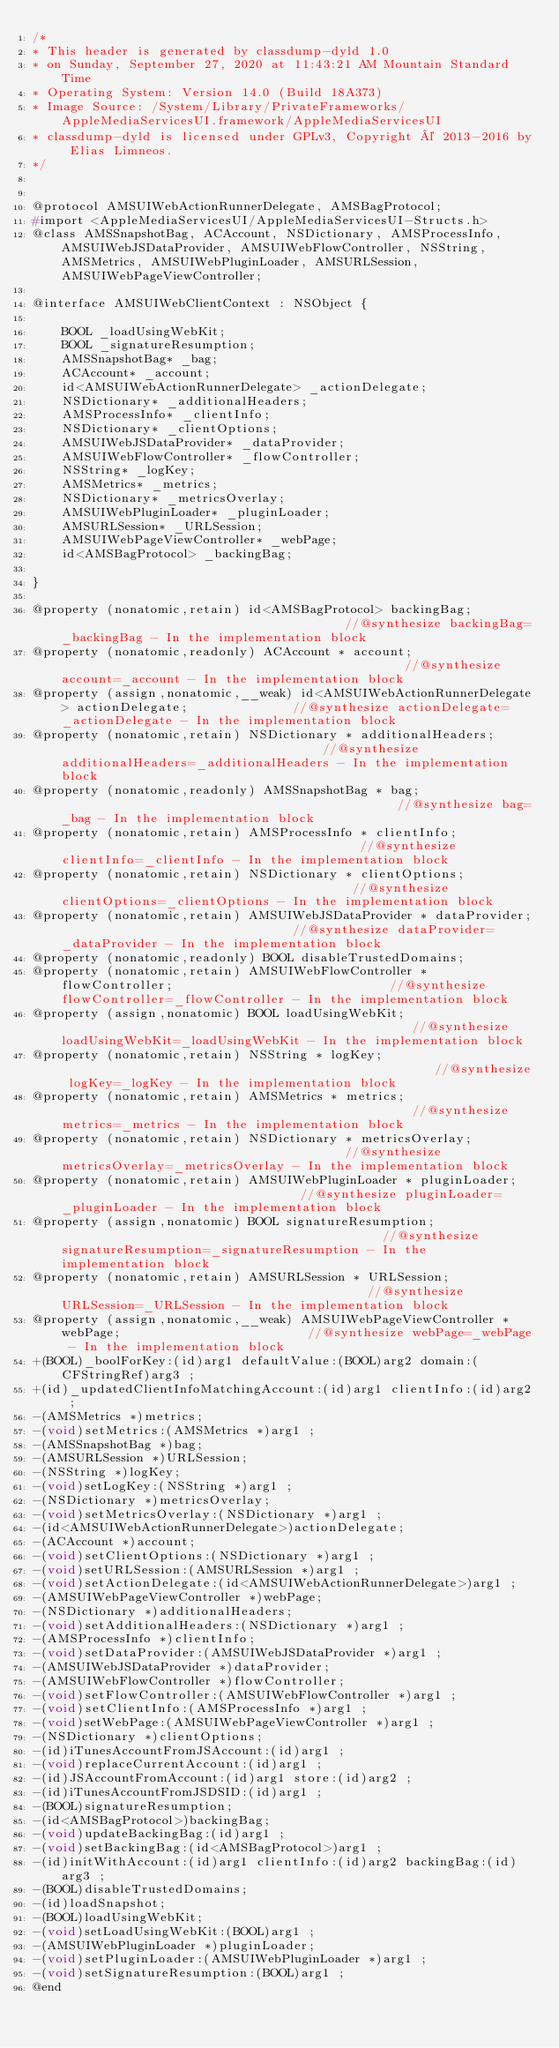<code> <loc_0><loc_0><loc_500><loc_500><_C_>/*
* This header is generated by classdump-dyld 1.0
* on Sunday, September 27, 2020 at 11:43:21 AM Mountain Standard Time
* Operating System: Version 14.0 (Build 18A373)
* Image Source: /System/Library/PrivateFrameworks/AppleMediaServicesUI.framework/AppleMediaServicesUI
* classdump-dyld is licensed under GPLv3, Copyright © 2013-2016 by Elias Limneos.
*/


@protocol AMSUIWebActionRunnerDelegate, AMSBagProtocol;
#import <AppleMediaServicesUI/AppleMediaServicesUI-Structs.h>
@class AMSSnapshotBag, ACAccount, NSDictionary, AMSProcessInfo, AMSUIWebJSDataProvider, AMSUIWebFlowController, NSString, AMSMetrics, AMSUIWebPluginLoader, AMSURLSession, AMSUIWebPageViewController;

@interface AMSUIWebClientContext : NSObject {

	BOOL _loadUsingWebKit;
	BOOL _signatureResumption;
	AMSSnapshotBag* _bag;
	ACAccount* _account;
	id<AMSUIWebActionRunnerDelegate> _actionDelegate;
	NSDictionary* _additionalHeaders;
	AMSProcessInfo* _clientInfo;
	NSDictionary* _clientOptions;
	AMSUIWebJSDataProvider* _dataProvider;
	AMSUIWebFlowController* _flowController;
	NSString* _logKey;
	AMSMetrics* _metrics;
	NSDictionary* _metricsOverlay;
	AMSUIWebPluginLoader* _pluginLoader;
	AMSURLSession* _URLSession;
	AMSUIWebPageViewController* _webPage;
	id<AMSBagProtocol> _backingBag;

}

@property (nonatomic,retain) id<AMSBagProtocol> backingBag;                                       //@synthesize backingBag=_backingBag - In the implementation block
@property (nonatomic,readonly) ACAccount * account;                                               //@synthesize account=_account - In the implementation block
@property (assign,nonatomic,__weak) id<AMSUIWebActionRunnerDelegate> actionDelegate;              //@synthesize actionDelegate=_actionDelegate - In the implementation block
@property (nonatomic,retain) NSDictionary * additionalHeaders;                                    //@synthesize additionalHeaders=_additionalHeaders - In the implementation block
@property (nonatomic,readonly) AMSSnapshotBag * bag;                                              //@synthesize bag=_bag - In the implementation block
@property (nonatomic,retain) AMSProcessInfo * clientInfo;                                         //@synthesize clientInfo=_clientInfo - In the implementation block
@property (nonatomic,retain) NSDictionary * clientOptions;                                        //@synthesize clientOptions=_clientOptions - In the implementation block
@property (nonatomic,retain) AMSUIWebJSDataProvider * dataProvider;                               //@synthesize dataProvider=_dataProvider - In the implementation block
@property (nonatomic,readonly) BOOL disableTrustedDomains; 
@property (nonatomic,retain) AMSUIWebFlowController * flowController;                             //@synthesize flowController=_flowController - In the implementation block
@property (assign,nonatomic) BOOL loadUsingWebKit;                                                //@synthesize loadUsingWebKit=_loadUsingWebKit - In the implementation block
@property (nonatomic,retain) NSString * logKey;                                                   //@synthesize logKey=_logKey - In the implementation block
@property (nonatomic,retain) AMSMetrics * metrics;                                                //@synthesize metrics=_metrics - In the implementation block
@property (nonatomic,retain) NSDictionary * metricsOverlay;                                       //@synthesize metricsOverlay=_metricsOverlay - In the implementation block
@property (nonatomic,retain) AMSUIWebPluginLoader * pluginLoader;                                 //@synthesize pluginLoader=_pluginLoader - In the implementation block
@property (assign,nonatomic) BOOL signatureResumption;                                            //@synthesize signatureResumption=_signatureResumption - In the implementation block
@property (nonatomic,retain) AMSURLSession * URLSession;                                          //@synthesize URLSession=_URLSession - In the implementation block
@property (assign,nonatomic,__weak) AMSUIWebPageViewController * webPage;                         //@synthesize webPage=_webPage - In the implementation block
+(BOOL)_boolForKey:(id)arg1 defaultValue:(BOOL)arg2 domain:(CFStringRef)arg3 ;
+(id)_updatedClientInfoMatchingAccount:(id)arg1 clientInfo:(id)arg2 ;
-(AMSMetrics *)metrics;
-(void)setMetrics:(AMSMetrics *)arg1 ;
-(AMSSnapshotBag *)bag;
-(AMSURLSession *)URLSession;
-(NSString *)logKey;
-(void)setLogKey:(NSString *)arg1 ;
-(NSDictionary *)metricsOverlay;
-(void)setMetricsOverlay:(NSDictionary *)arg1 ;
-(id<AMSUIWebActionRunnerDelegate>)actionDelegate;
-(ACAccount *)account;
-(void)setClientOptions:(NSDictionary *)arg1 ;
-(void)setURLSession:(AMSURLSession *)arg1 ;
-(void)setActionDelegate:(id<AMSUIWebActionRunnerDelegate>)arg1 ;
-(AMSUIWebPageViewController *)webPage;
-(NSDictionary *)additionalHeaders;
-(void)setAdditionalHeaders:(NSDictionary *)arg1 ;
-(AMSProcessInfo *)clientInfo;
-(void)setDataProvider:(AMSUIWebJSDataProvider *)arg1 ;
-(AMSUIWebJSDataProvider *)dataProvider;
-(AMSUIWebFlowController *)flowController;
-(void)setFlowController:(AMSUIWebFlowController *)arg1 ;
-(void)setClientInfo:(AMSProcessInfo *)arg1 ;
-(void)setWebPage:(AMSUIWebPageViewController *)arg1 ;
-(NSDictionary *)clientOptions;
-(id)iTunesAccountFromJSAccount:(id)arg1 ;
-(void)replaceCurrentAccount:(id)arg1 ;
-(id)JSAccountFromAccount:(id)arg1 store:(id)arg2 ;
-(id)iTunesAccountFromJSDSID:(id)arg1 ;
-(BOOL)signatureResumption;
-(id<AMSBagProtocol>)backingBag;
-(void)updateBackingBag:(id)arg1 ;
-(void)setBackingBag:(id<AMSBagProtocol>)arg1 ;
-(id)initWithAccount:(id)arg1 clientInfo:(id)arg2 backingBag:(id)arg3 ;
-(BOOL)disableTrustedDomains;
-(id)loadSnapshot;
-(BOOL)loadUsingWebKit;
-(void)setLoadUsingWebKit:(BOOL)arg1 ;
-(AMSUIWebPluginLoader *)pluginLoader;
-(void)setPluginLoader:(AMSUIWebPluginLoader *)arg1 ;
-(void)setSignatureResumption:(BOOL)arg1 ;
@end

</code> 